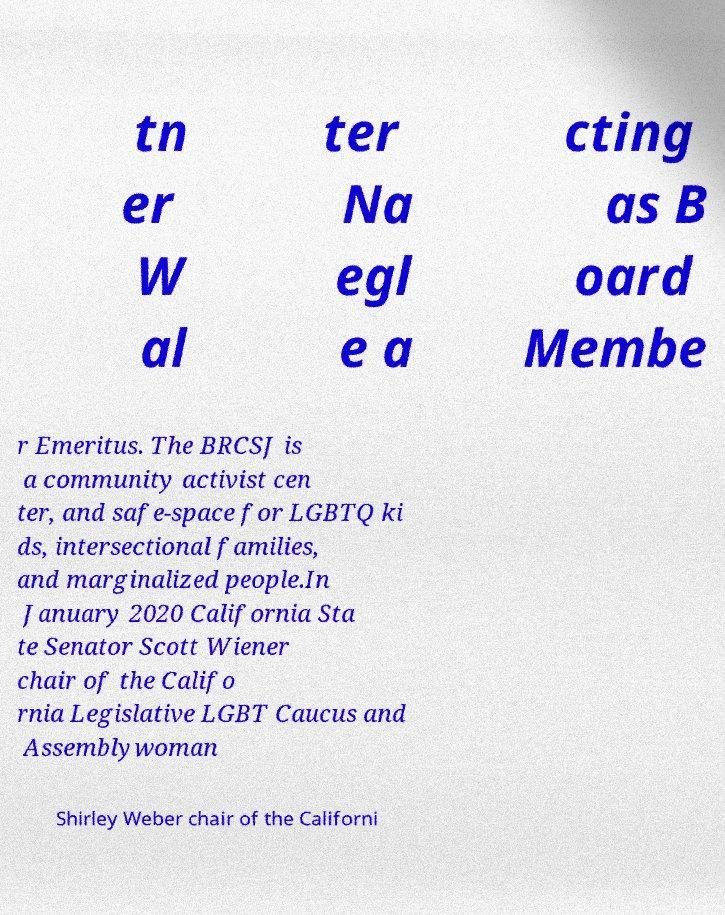Could you extract and type out the text from this image? tn er W al ter Na egl e a cting as B oard Membe r Emeritus. The BRCSJ is a community activist cen ter, and safe-space for LGBTQ ki ds, intersectional families, and marginalized people.In January 2020 California Sta te Senator Scott Wiener chair of the Califo rnia Legislative LGBT Caucus and Assemblywoman Shirley Weber chair of the Californi 